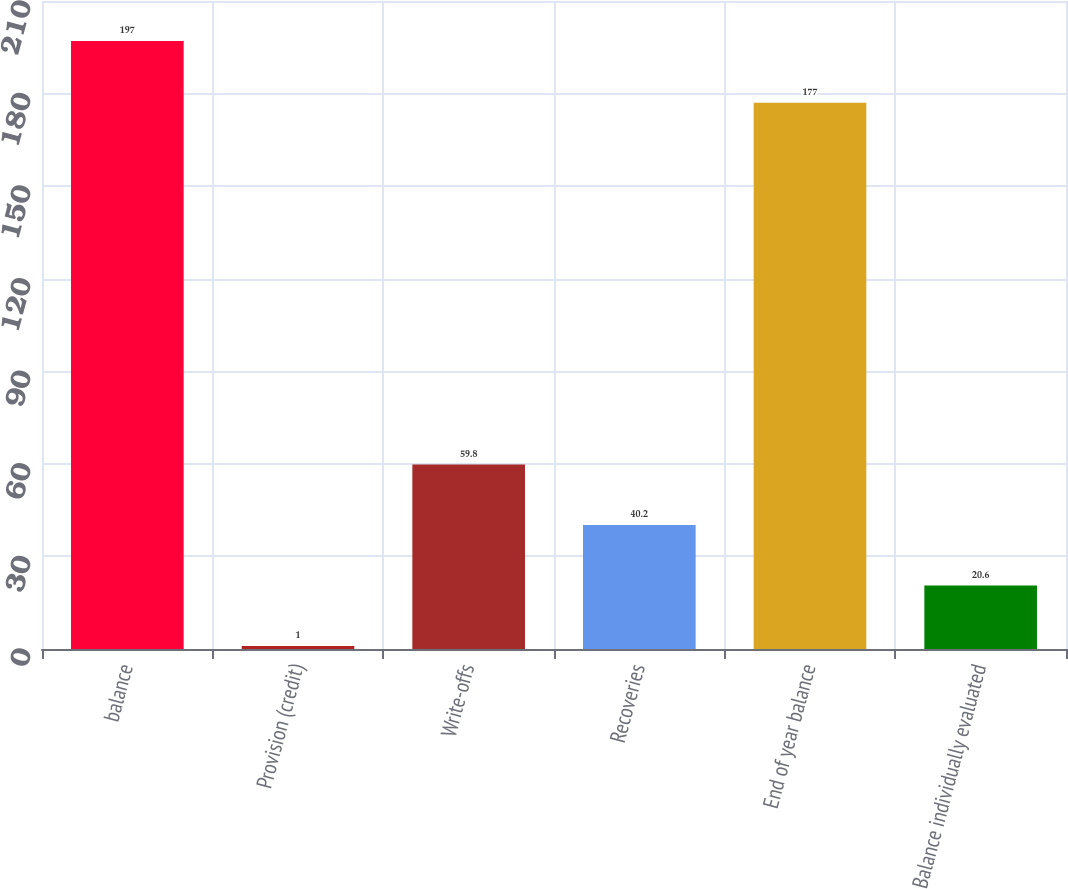Convert chart. <chart><loc_0><loc_0><loc_500><loc_500><bar_chart><fcel>balance<fcel>Provision (credit)<fcel>Write-offs<fcel>Recoveries<fcel>End of year balance<fcel>Balance individually evaluated<nl><fcel>197<fcel>1<fcel>59.8<fcel>40.2<fcel>177<fcel>20.6<nl></chart> 